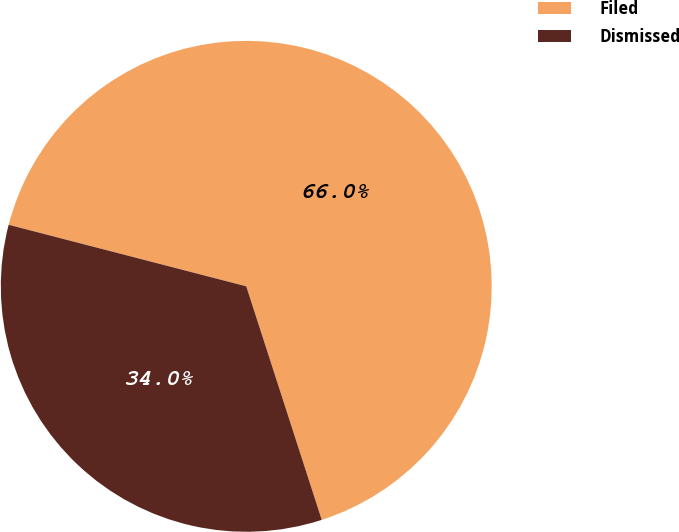Convert chart to OTSL. <chart><loc_0><loc_0><loc_500><loc_500><pie_chart><fcel>Filed<fcel>Dismissed<nl><fcel>65.99%<fcel>34.01%<nl></chart> 